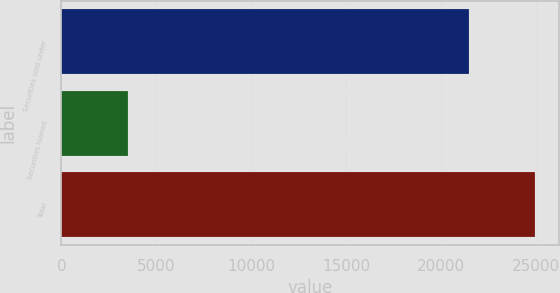Convert chart to OTSL. <chart><loc_0><loc_0><loc_500><loc_500><bar_chart><fcel>Securities sold under<fcel>Securities loaned<fcel>Total<nl><fcel>21476<fcel>3506<fcel>24982<nl></chart> 